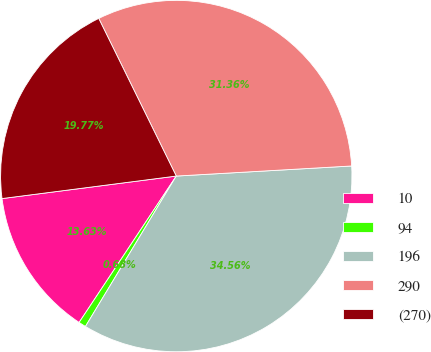Convert chart. <chart><loc_0><loc_0><loc_500><loc_500><pie_chart><fcel>10<fcel>94<fcel>196<fcel>290<fcel>(270)<nl><fcel>13.63%<fcel>0.68%<fcel>34.56%<fcel>31.36%<fcel>19.77%<nl></chart> 